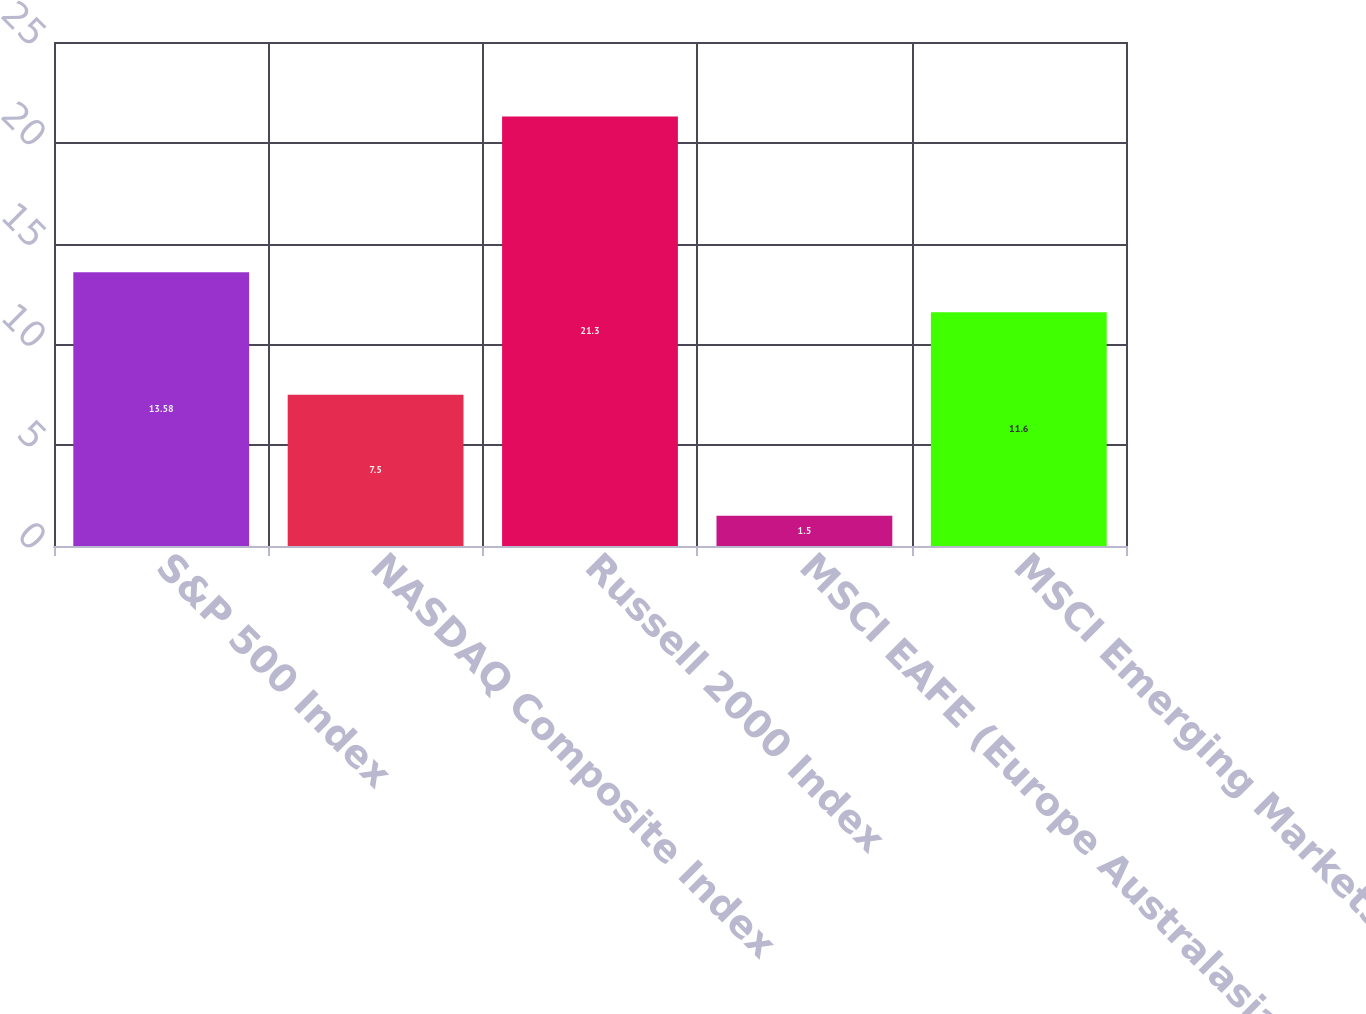Convert chart to OTSL. <chart><loc_0><loc_0><loc_500><loc_500><bar_chart><fcel>S&P 500 Index<fcel>NASDAQ Composite Index<fcel>Russell 2000 Index<fcel>MSCI EAFE (Europe Australasia<fcel>MSCI Emerging Markets Index<nl><fcel>13.58<fcel>7.5<fcel>21.3<fcel>1.5<fcel>11.6<nl></chart> 